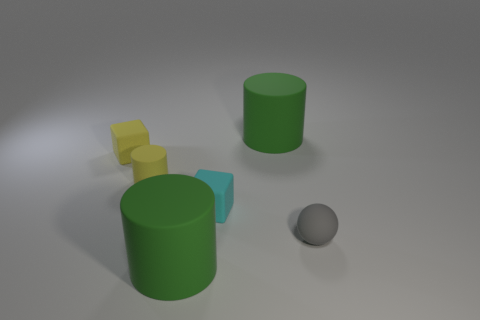Add 2 small cyan matte things. How many objects exist? 8 Subtract all purple blocks. How many yellow cylinders are left? 1 Subtract all small gray rubber spheres. Subtract all small cyan blocks. How many objects are left? 4 Add 1 spheres. How many spheres are left? 2 Add 2 tiny gray balls. How many tiny gray balls exist? 3 Subtract all cyan blocks. How many blocks are left? 1 Subtract all small cylinders. How many cylinders are left? 2 Subtract 0 gray cubes. How many objects are left? 6 Subtract all blocks. How many objects are left? 4 Subtract 1 blocks. How many blocks are left? 1 